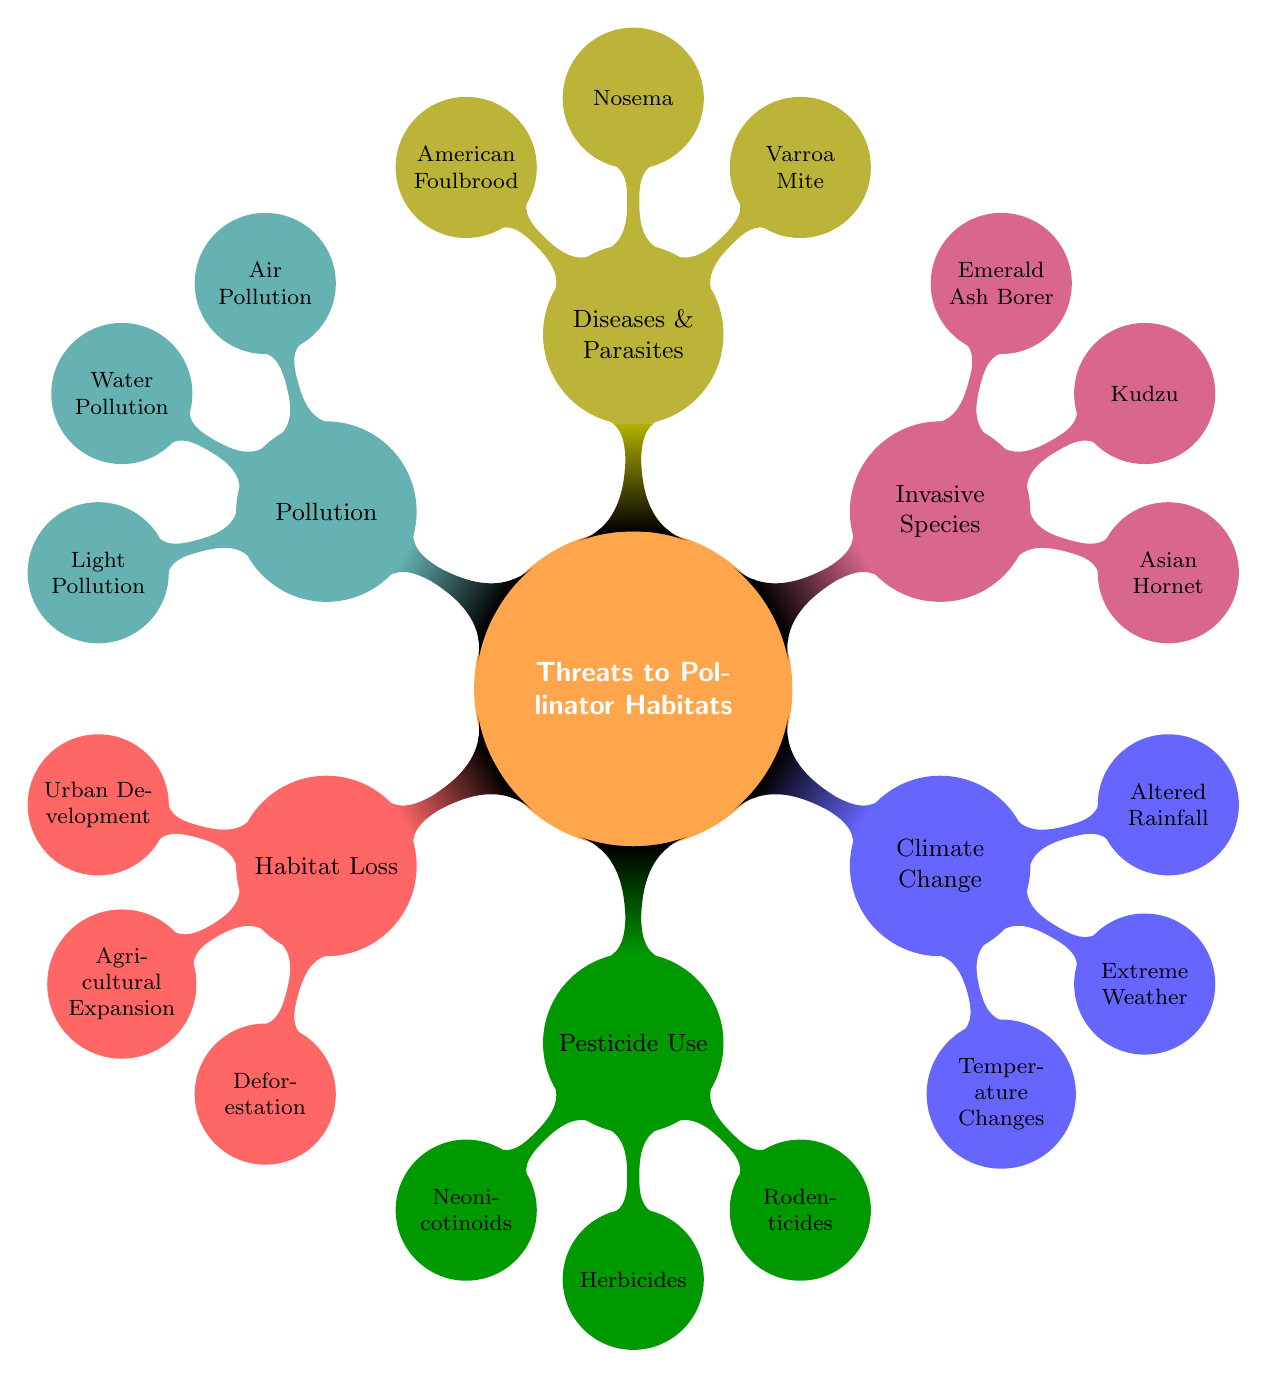What is the main category represented in the diagram? The main category is represented at the top of the mind map as 'Threats to Pollinator Habitats', which is the central theme around which all other nodes are organized.
Answer: Threats to Pollinator Habitats How many primary threats are identified in the diagram? The diagram branches out into six primary threats, each identified by a distinct node stemming from the central theme.
Answer: Six What is one specific example of Habitat Loss? Under the 'Habitat Loss' node, one example is 'Urban Development', which indicates a specific aspect of habitat loss affecting pollinators.
Answer: Urban Development Which pesticide type is specifically harmful to bees? The 'Pesticide Use' node lists 'Neonicotinoids' as a commonly used class of insecticides that are particularly harmful to bees.
Answer: Neonicotinoids Name an invasive species listed in the diagram. The node 'Invasive Species' includes 'Asian Hornet' as one of the examples of invasive species that threatens pollinators.
Answer: Asian Hornet What does climate change affect in relation to pollinators? The 'Climate Change' branch identifies that 'Temperature Changes' directly influence the bloom times of plants and the life cycles of pollinators.
Answer: Temperature Changes How does light pollution impact pollinators? Under the 'Pollution' node, 'Light Pollution' is noted for disrupting nocturnal pollinators and their feeding patterns, illustrating its impact.
Answer: Disrupting nocturnal pollinators Which disease affects bee larvae specifically? The node under 'Diseases & Parasites' states that 'American Foulbrood' is a bacterial disease affecting bee larvae, indicating its specific target.
Answer: American Foulbrood How do extreme weather events relate to climate change? 'Extreme Weather' is a sub-node under 'Climate Change', indicating that such events, like storms and droughts, can disrupt habitats for pollinators, demonstrating a direct relationship.
Answer: Disrupting habitats 